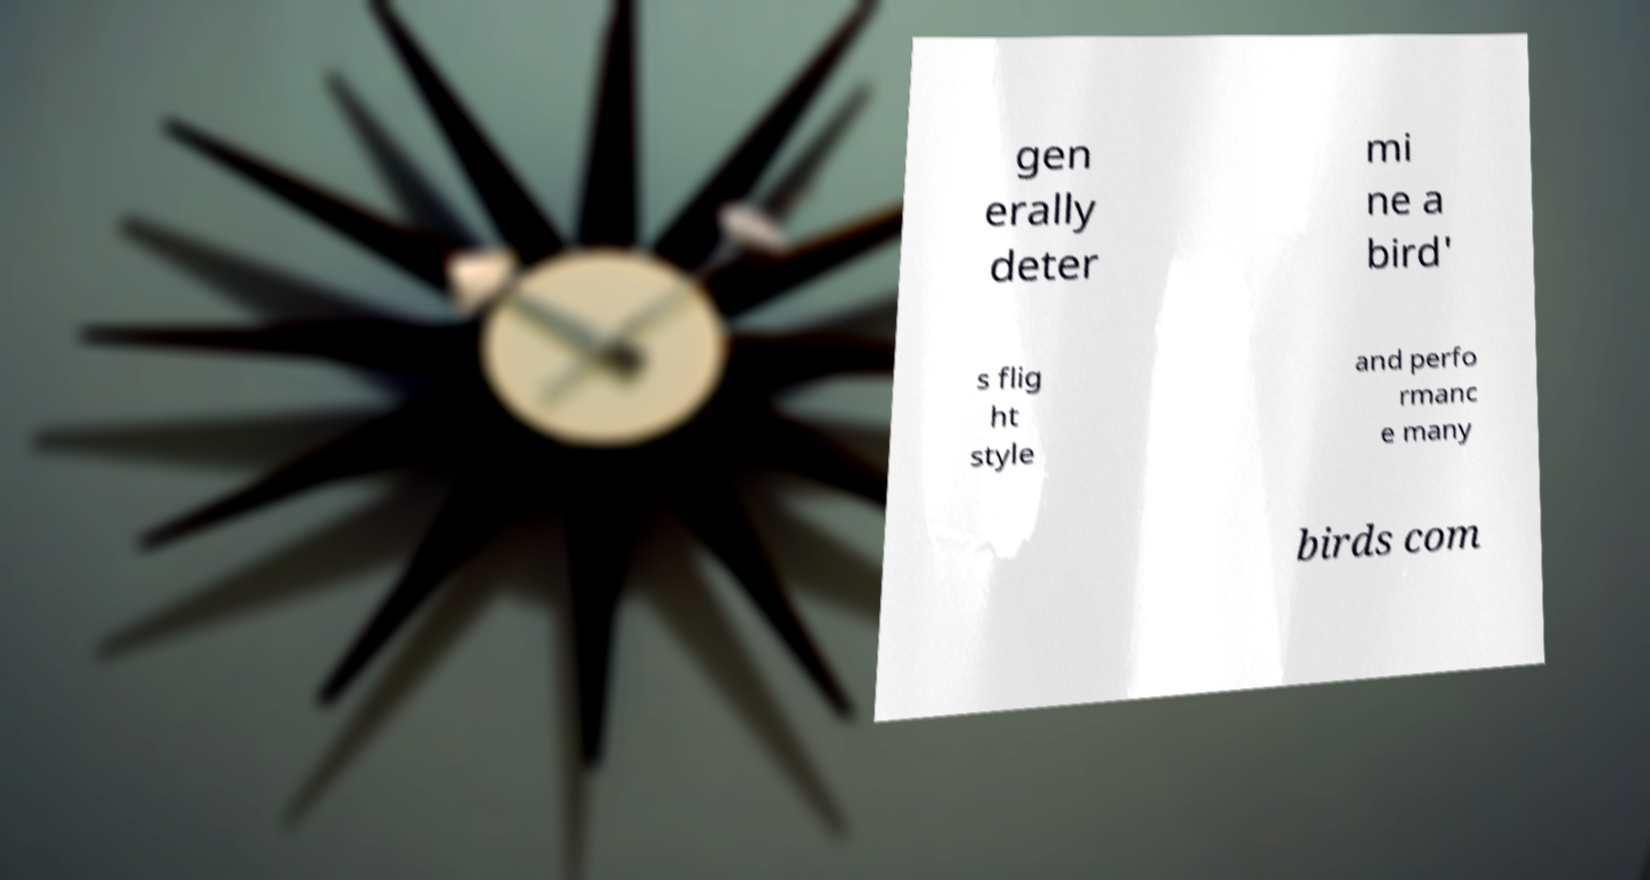Please read and relay the text visible in this image. What does it say? gen erally deter mi ne a bird' s flig ht style and perfo rmanc e many birds com 